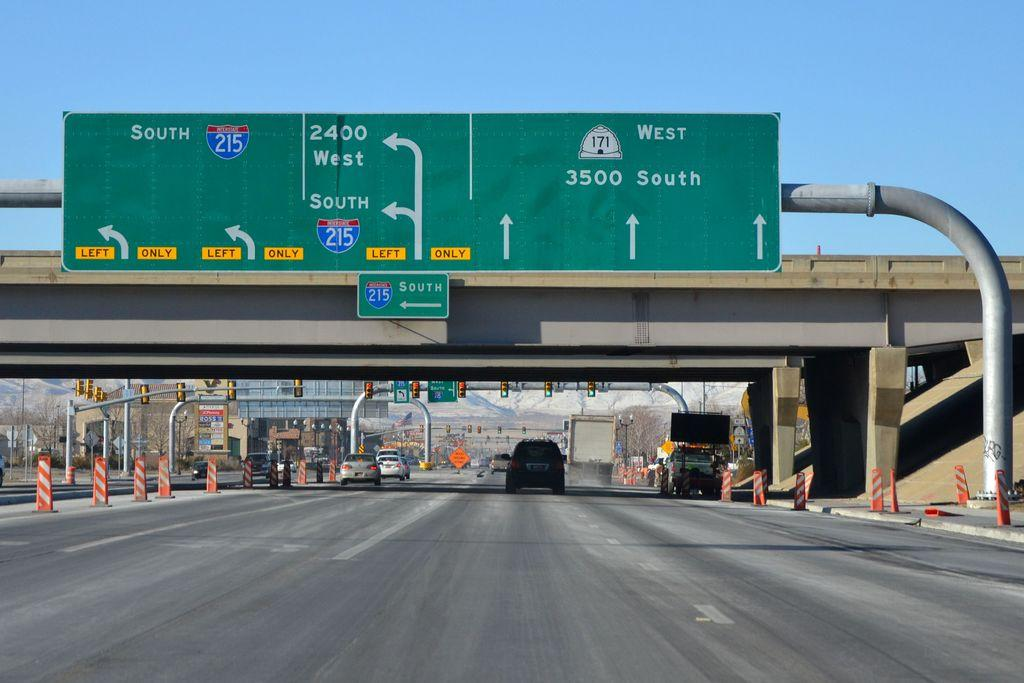<image>
Summarize the visual content of the image. A road signs marks exits to the south and west. 